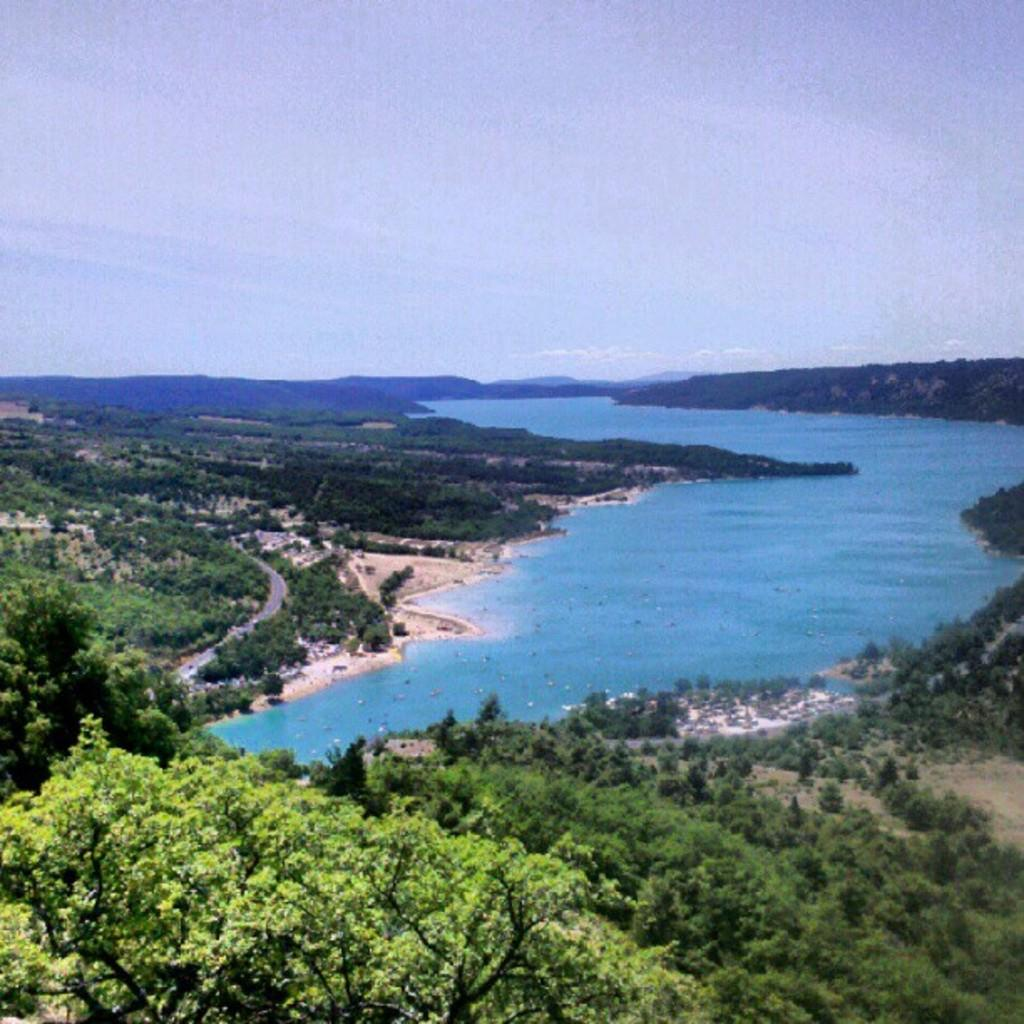What type of vegetation can be seen in the image? There are trees in the image. What else is visible besides the trees? There is water and a road visible in the image. What is visible at the top of the image? The sky is visible at the top of the image. What type of art can be seen in the field in the image? There is no art or field present in the image; it features trees, water, a road, and the sky. 